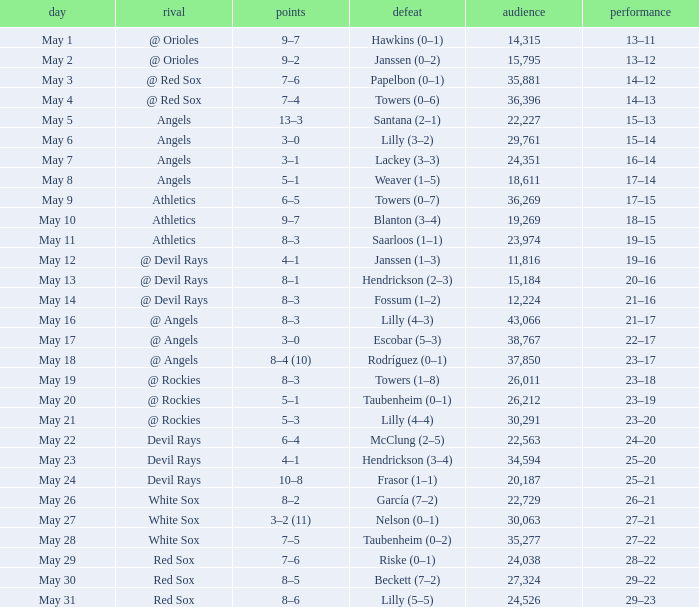Could you help me parse every detail presented in this table? {'header': ['day', 'rival', 'points', 'defeat', 'audience', 'performance'], 'rows': [['May 1', '@ Orioles', '9–7', 'Hawkins (0–1)', '14,315', '13–11'], ['May 2', '@ Orioles', '9–2', 'Janssen (0–2)', '15,795', '13–12'], ['May 3', '@ Red Sox', '7–6', 'Papelbon (0–1)', '35,881', '14–12'], ['May 4', '@ Red Sox', '7–4', 'Towers (0–6)', '36,396', '14–13'], ['May 5', 'Angels', '13–3', 'Santana (2–1)', '22,227', '15–13'], ['May 6', 'Angels', '3–0', 'Lilly (3–2)', '29,761', '15–14'], ['May 7', 'Angels', '3–1', 'Lackey (3–3)', '24,351', '16–14'], ['May 8', 'Angels', '5–1', 'Weaver (1–5)', '18,611', '17–14'], ['May 9', 'Athletics', '6–5', 'Towers (0–7)', '36,269', '17–15'], ['May 10', 'Athletics', '9–7', 'Blanton (3–4)', '19,269', '18–15'], ['May 11', 'Athletics', '8–3', 'Saarloos (1–1)', '23,974', '19–15'], ['May 12', '@ Devil Rays', '4–1', 'Janssen (1–3)', '11,816', '19–16'], ['May 13', '@ Devil Rays', '8–1', 'Hendrickson (2–3)', '15,184', '20–16'], ['May 14', '@ Devil Rays', '8–3', 'Fossum (1–2)', '12,224', '21–16'], ['May 16', '@ Angels', '8–3', 'Lilly (4–3)', '43,066', '21–17'], ['May 17', '@ Angels', '3–0', 'Escobar (5–3)', '38,767', '22–17'], ['May 18', '@ Angels', '8–4 (10)', 'Rodríguez (0–1)', '37,850', '23–17'], ['May 19', '@ Rockies', '8–3', 'Towers (1–8)', '26,011', '23–18'], ['May 20', '@ Rockies', '5–1', 'Taubenheim (0–1)', '26,212', '23–19'], ['May 21', '@ Rockies', '5–3', 'Lilly (4–4)', '30,291', '23–20'], ['May 22', 'Devil Rays', '6–4', 'McClung (2–5)', '22,563', '24–20'], ['May 23', 'Devil Rays', '4–1', 'Hendrickson (3–4)', '34,594', '25–20'], ['May 24', 'Devil Rays', '10–8', 'Frasor (1–1)', '20,187', '25–21'], ['May 26', 'White Sox', '8–2', 'García (7–2)', '22,729', '26–21'], ['May 27', 'White Sox', '3–2 (11)', 'Nelson (0–1)', '30,063', '27–21'], ['May 28', 'White Sox', '7–5', 'Taubenheim (0–2)', '35,277', '27–22'], ['May 29', 'Red Sox', '7–6', 'Riske (0–1)', '24,038', '28–22'], ['May 30', 'Red Sox', '8–5', 'Beckett (7–2)', '27,324', '29–22'], ['May 31', 'Red Sox', '8–6', 'Lilly (5–5)', '24,526', '29–23']]} When the team had their record of 16–14, what was the total attendance? 1.0. 